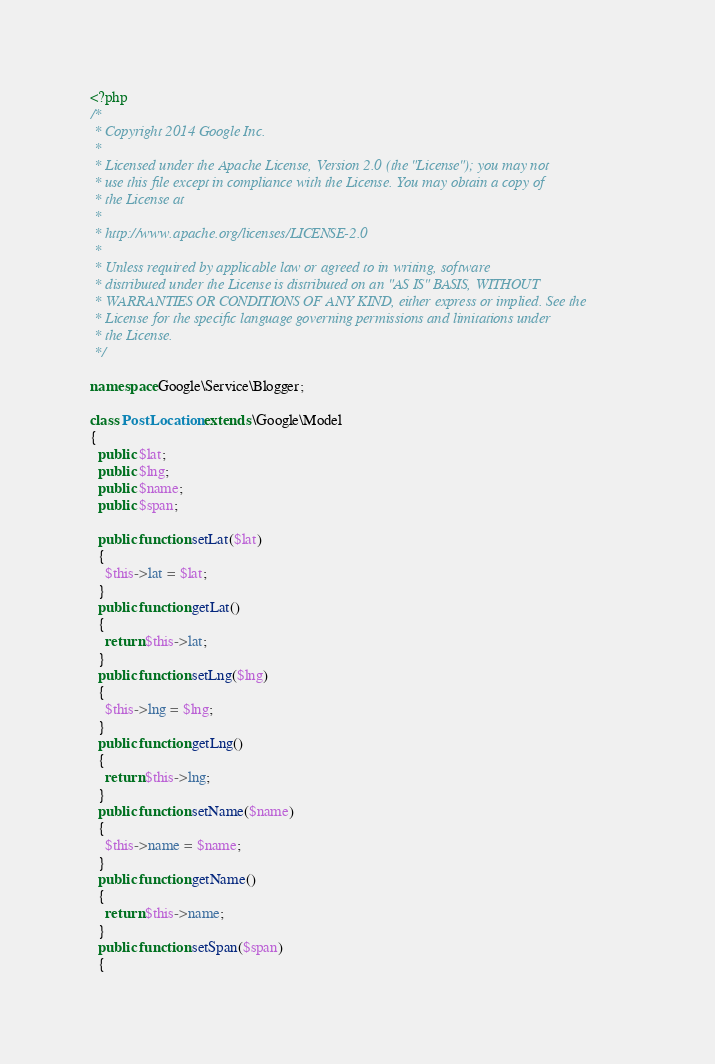Convert code to text. <code><loc_0><loc_0><loc_500><loc_500><_PHP_><?php
/*
 * Copyright 2014 Google Inc.
 *
 * Licensed under the Apache License, Version 2.0 (the "License"); you may not
 * use this file except in compliance with the License. You may obtain a copy of
 * the License at
 *
 * http://www.apache.org/licenses/LICENSE-2.0
 *
 * Unless required by applicable law or agreed to in writing, software
 * distributed under the License is distributed on an "AS IS" BASIS, WITHOUT
 * WARRANTIES OR CONDITIONS OF ANY KIND, either express or implied. See the
 * License for the specific language governing permissions and limitations under
 * the License.
 */

namespace Google\Service\Blogger;

class PostLocation extends \Google\Model
{
  public $lat;
  public $lng;
  public $name;
  public $span;

  public function setLat($lat)
  {
    $this->lat = $lat;
  }
  public function getLat()
  {
    return $this->lat;
  }
  public function setLng($lng)
  {
    $this->lng = $lng;
  }
  public function getLng()
  {
    return $this->lng;
  }
  public function setName($name)
  {
    $this->name = $name;
  }
  public function getName()
  {
    return $this->name;
  }
  public function setSpan($span)
  {</code> 